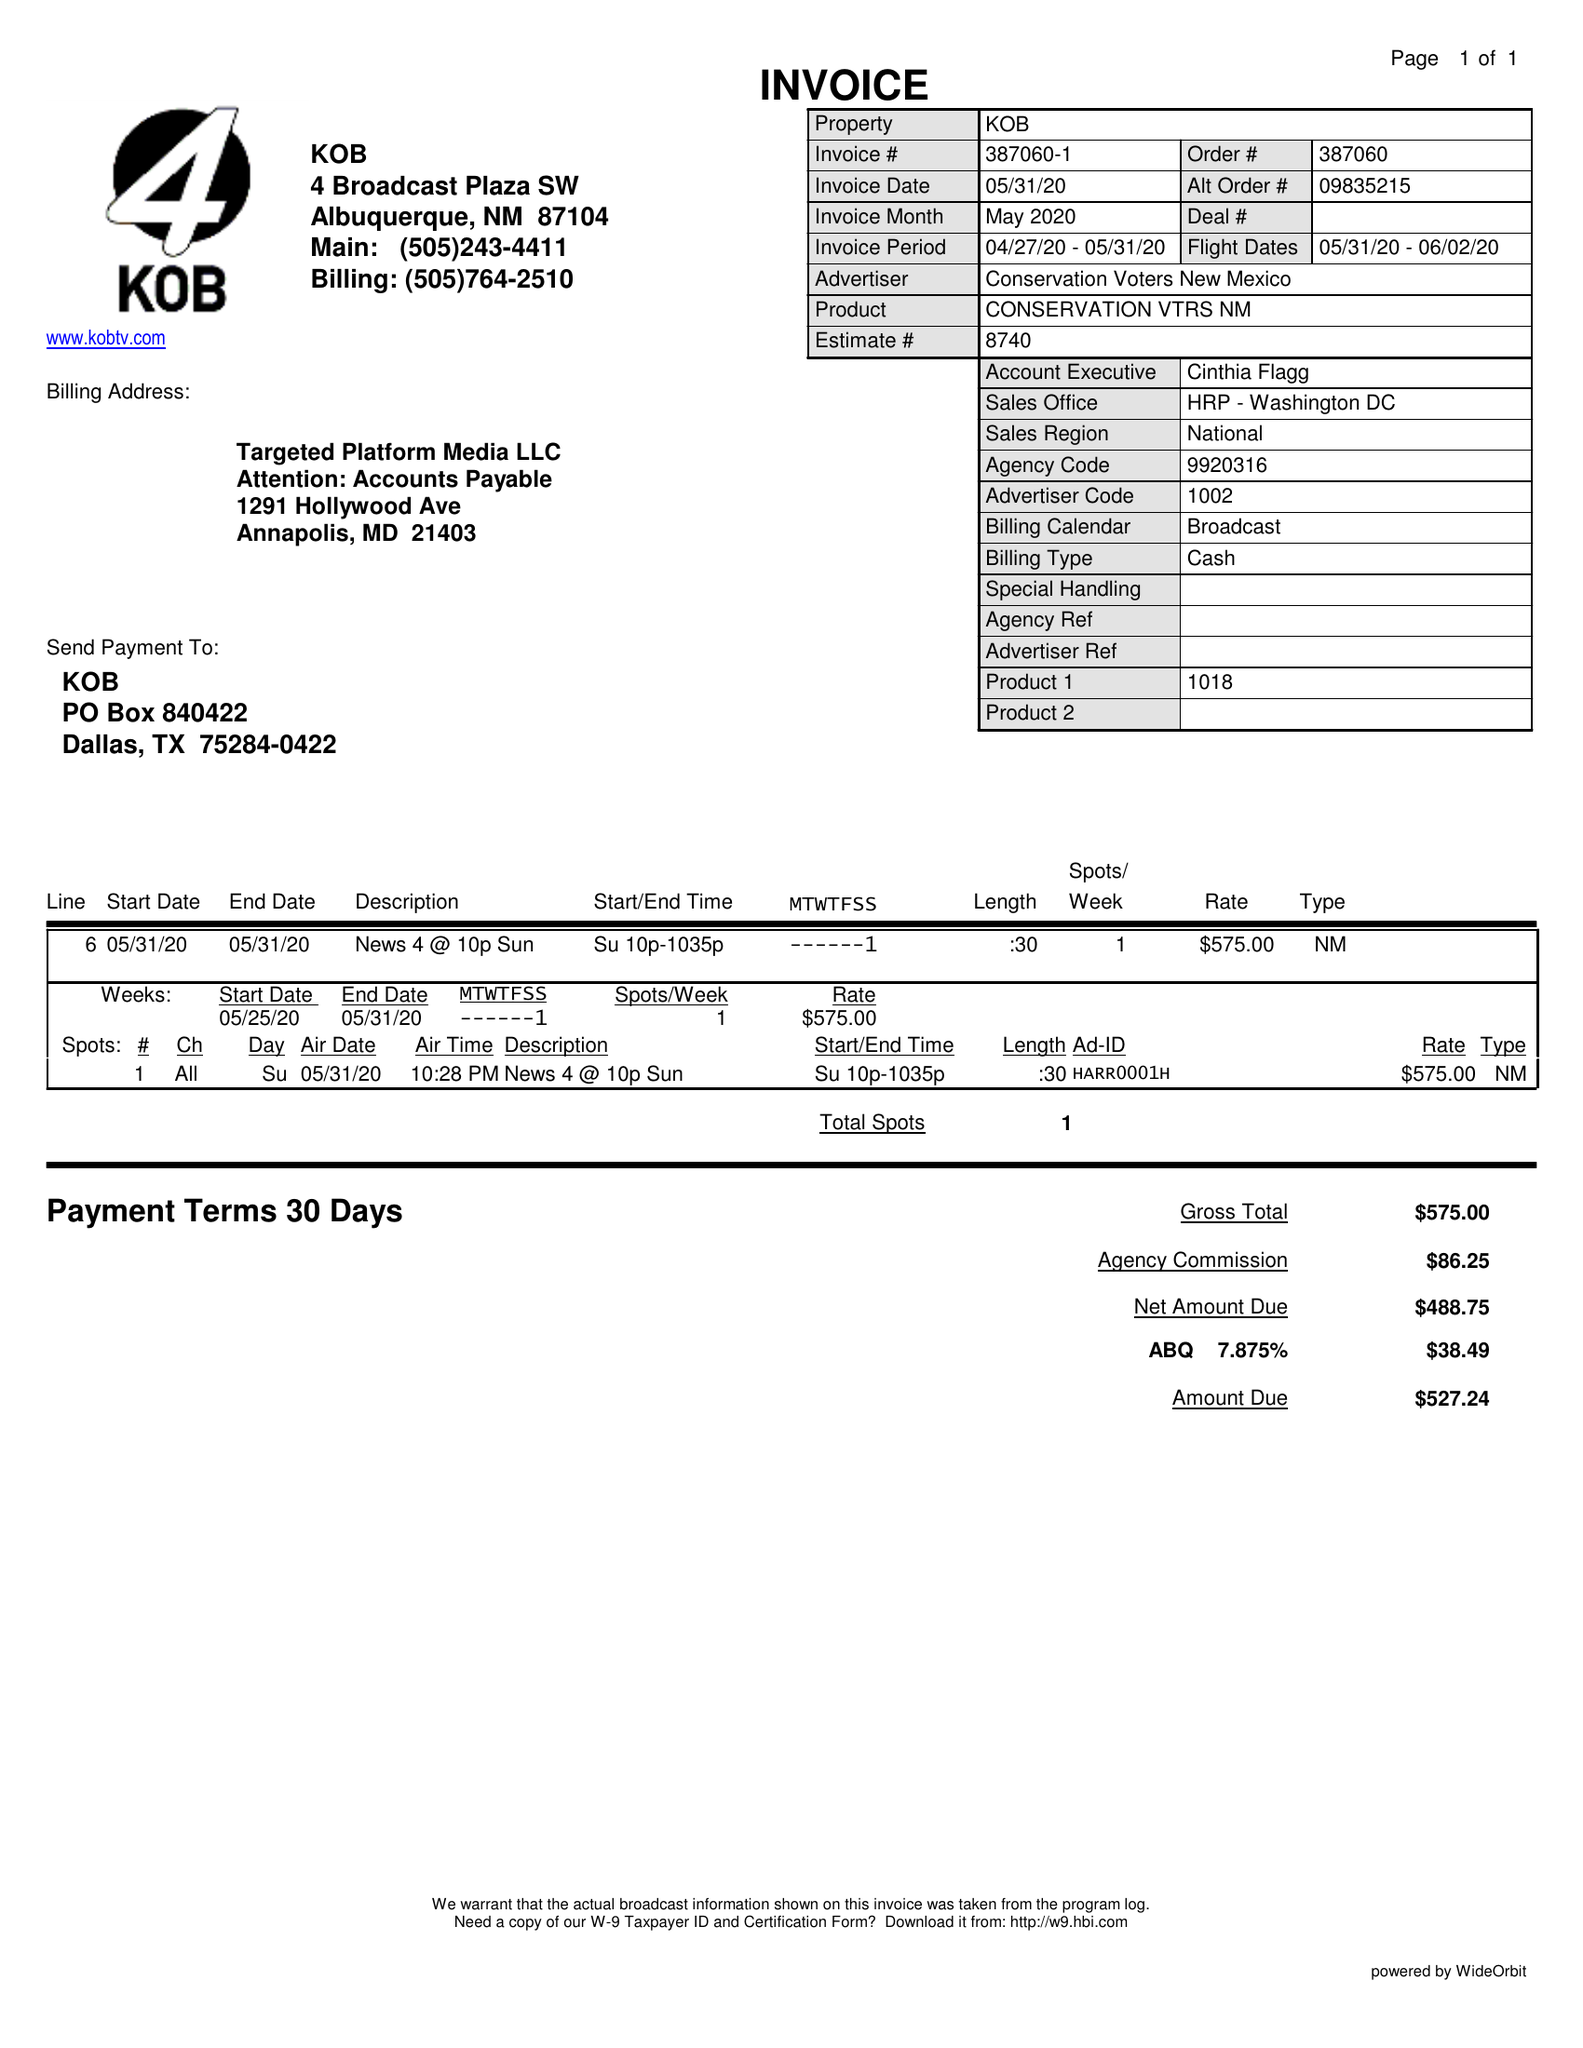What is the value for the contract_num?
Answer the question using a single word or phrase. 387060 